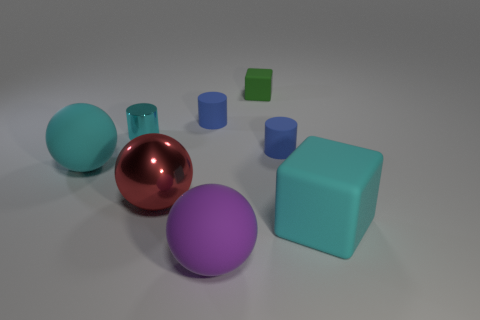Add 2 red metal balls. How many objects exist? 10 Subtract all cubes. How many objects are left? 6 Add 6 cyan objects. How many cyan objects exist? 9 Subtract 0 red cubes. How many objects are left? 8 Subtract all blue matte things. Subtract all purple balls. How many objects are left? 5 Add 5 green matte blocks. How many green matte blocks are left? 6 